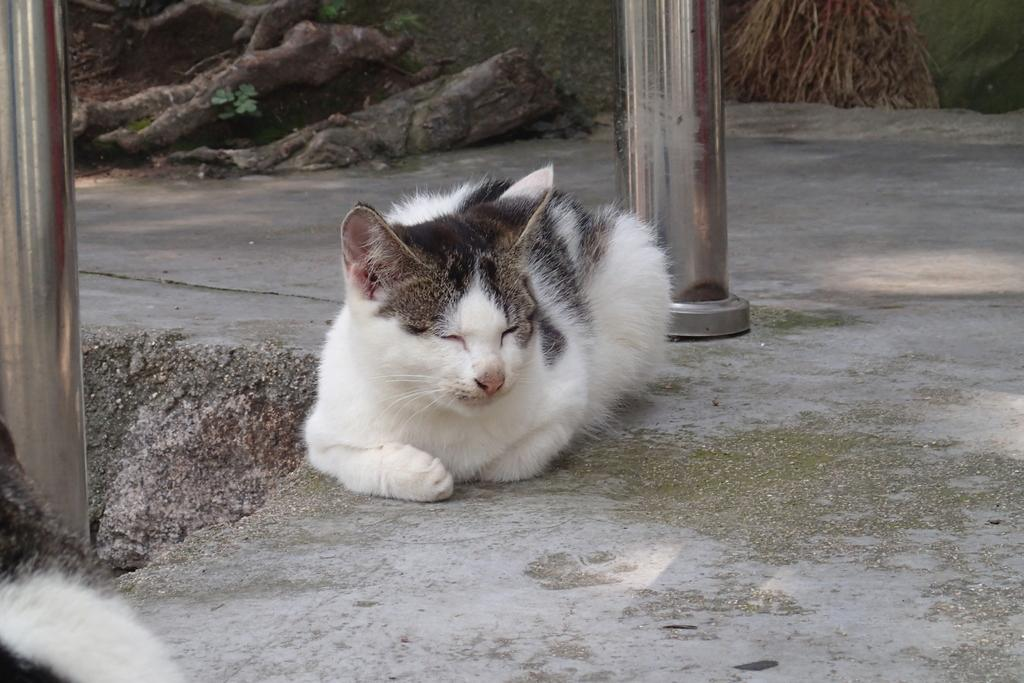What type of animal is present in the image? There is a cat in the image. What is located behind the cat? There are wooden logs behind the cat. What architectural features can be seen in the image? There are pillars in the image. Are there any other animals present in the image? Yes, there is another cat on the left side of the image. What type of paint is being used by the stranger in the image? There is no stranger present in the image, and therefore no paint or painting activity can be observed. 